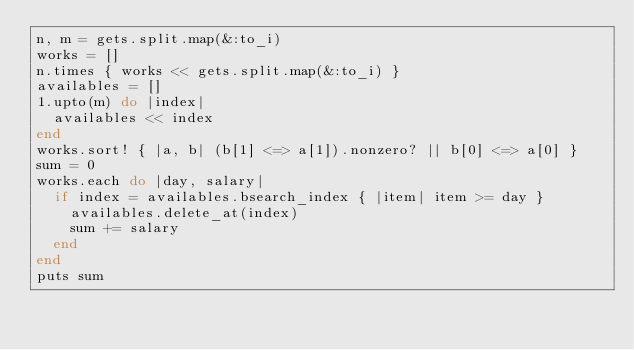<code> <loc_0><loc_0><loc_500><loc_500><_Ruby_>n, m = gets.split.map(&:to_i)
works = []
n.times { works << gets.split.map(&:to_i) }
availables = []
1.upto(m) do |index|
  availables << index
end
works.sort! { |a, b| (b[1] <=> a[1]).nonzero? || b[0] <=> a[0] }
sum = 0
works.each do |day, salary|
  if index = availables.bsearch_index { |item| item >= day }
    availables.delete_at(index)
    sum += salary
  end
end
puts sum
</code> 